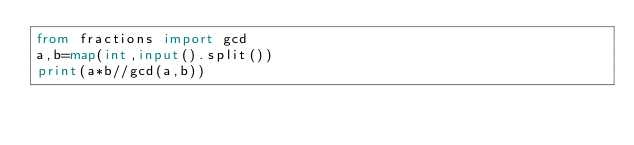<code> <loc_0><loc_0><loc_500><loc_500><_Python_>from fractions import gcd
a,b=map(int,input().split())
print(a*b//gcd(a,b))</code> 